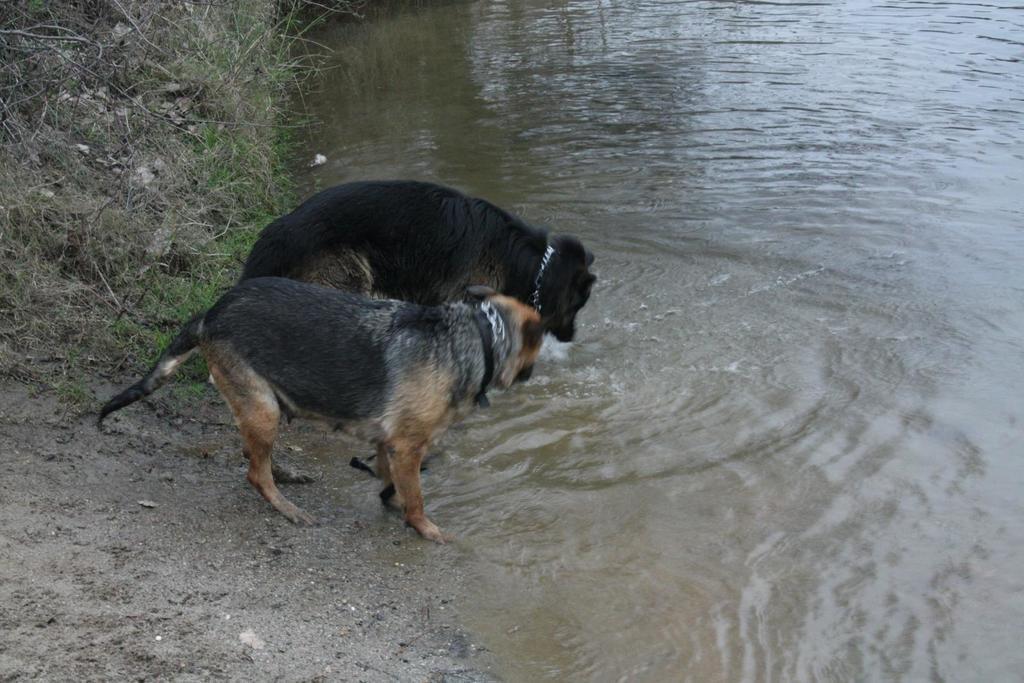How would you summarize this image in a sentence or two? On the right side of this image there is a river. In the middle of the image there are two dogs drinking the water. On the left side, I can see the ground. There are few sticks and stones on the ground. 